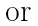Convert formula to latex. <formula><loc_0><loc_0><loc_500><loc_500>\text {or}</formula> 